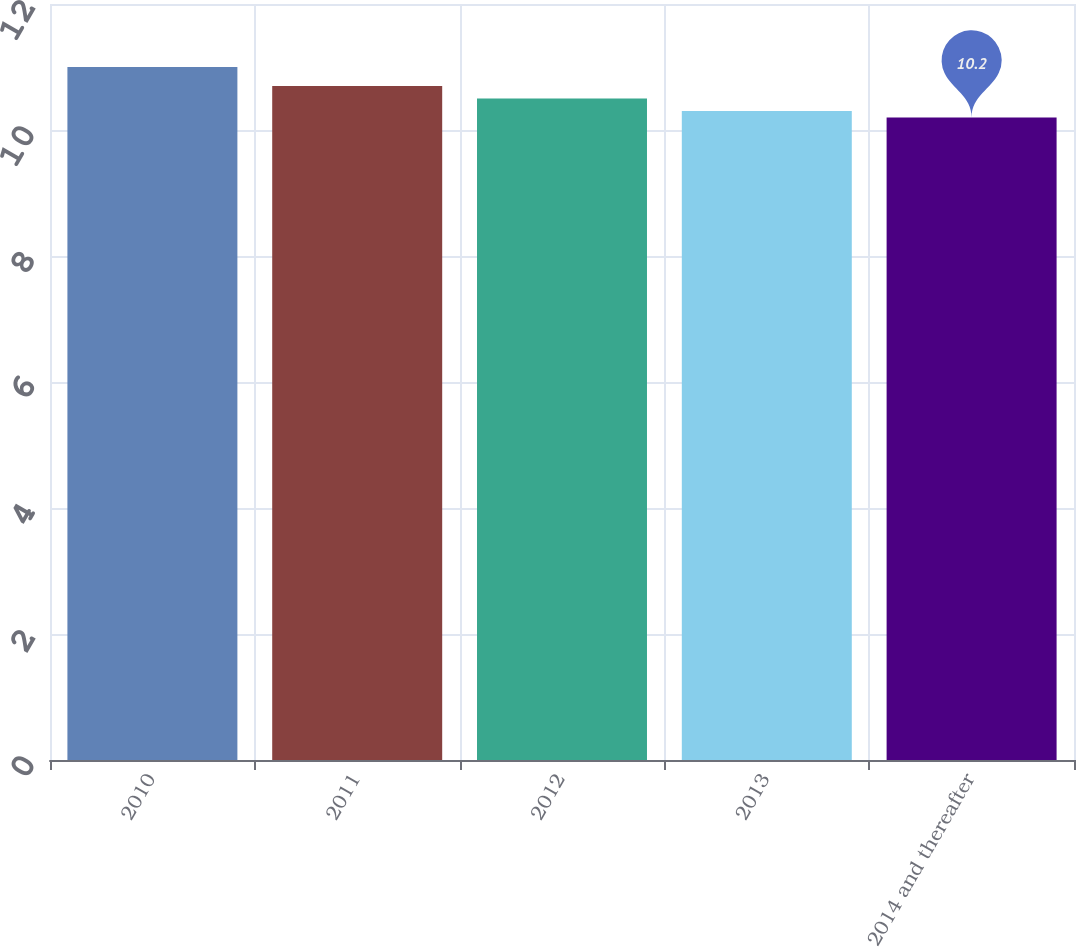Convert chart. <chart><loc_0><loc_0><loc_500><loc_500><bar_chart><fcel>2010<fcel>2011<fcel>2012<fcel>2013<fcel>2014 and thereafter<nl><fcel>11<fcel>10.7<fcel>10.5<fcel>10.3<fcel>10.2<nl></chart> 